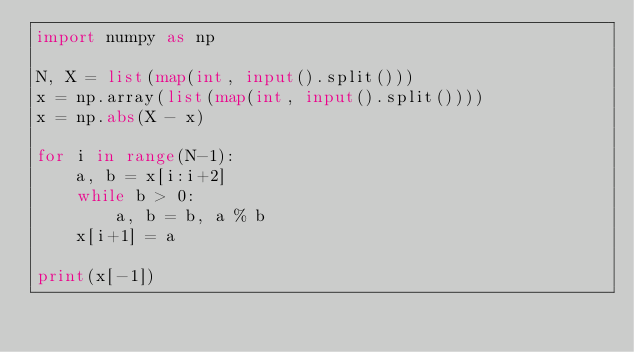<code> <loc_0><loc_0><loc_500><loc_500><_Python_>import numpy as np

N, X = list(map(int, input().split()))
x = np.array(list(map(int, input().split())))
x = np.abs(X - x)

for i in range(N-1):
    a, b = x[i:i+2]
    while b > 0:
        a, b = b, a % b
    x[i+1] = a

print(x[-1])
</code> 